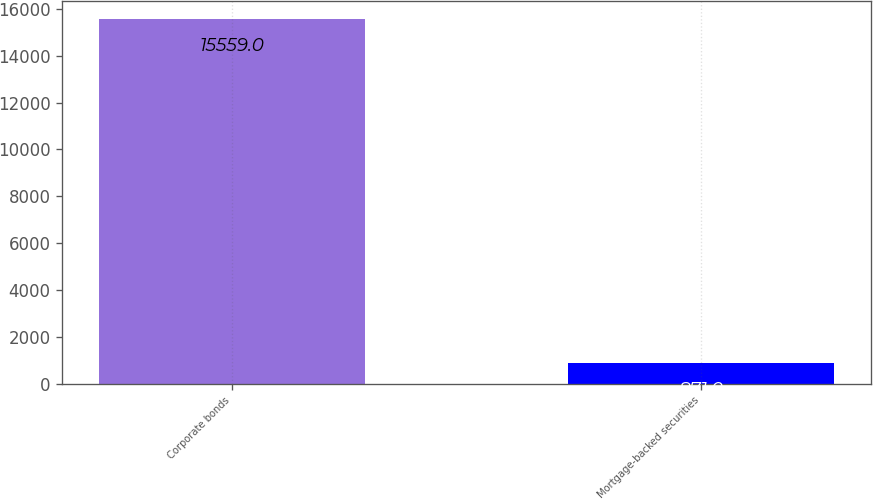Convert chart. <chart><loc_0><loc_0><loc_500><loc_500><bar_chart><fcel>Corporate bonds<fcel>Mortgage-backed securities<nl><fcel>15559<fcel>871<nl></chart> 